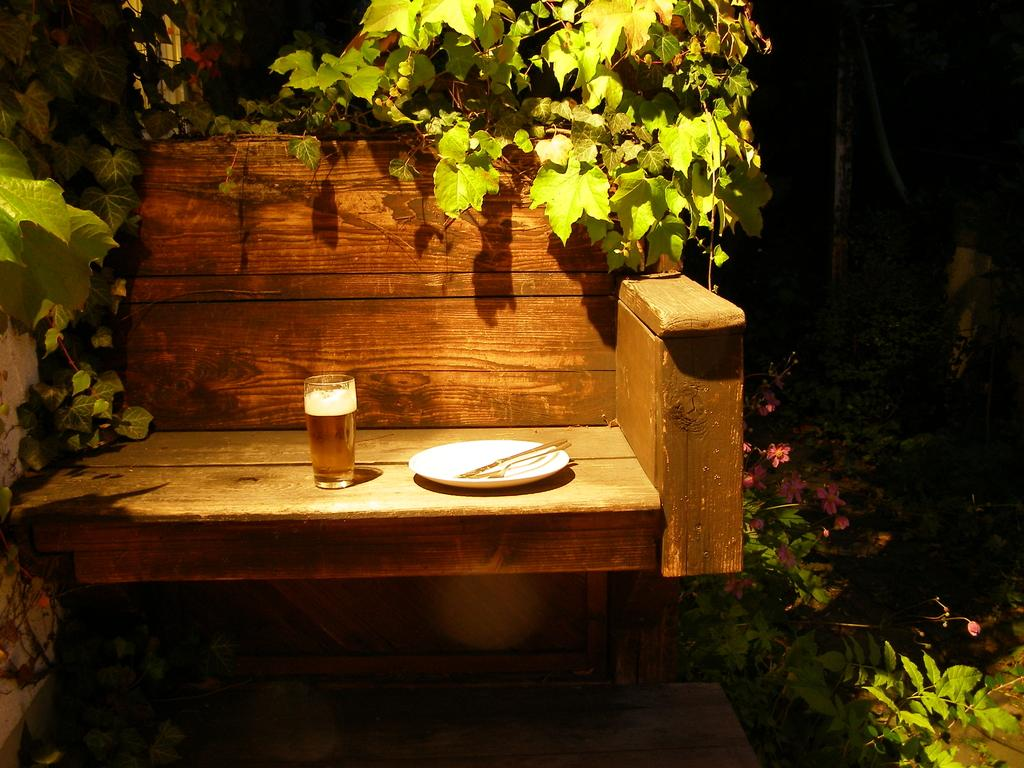What type of chair is in the image? There is a wooden chair in the image. Where is the wooden chair located in the image? The wooden chair is on the left side of the image. What items are on the wooden chair? There is a plate and a glass on the wooden chair. What can be seen on both sides of the image? There are plants on both the left and right sides of the image. What team is responsible for maintaining the plants in the image? There is no team present in the image, and the plants' maintenance is not mentioned. 